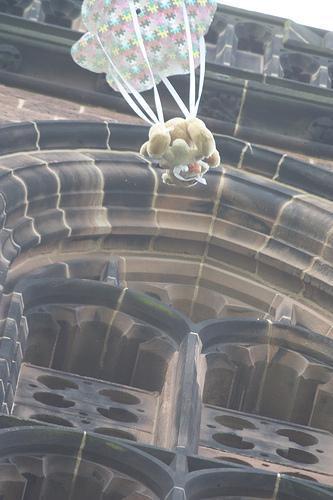How many teddy bears are in the photo?
Give a very brief answer. 1. 